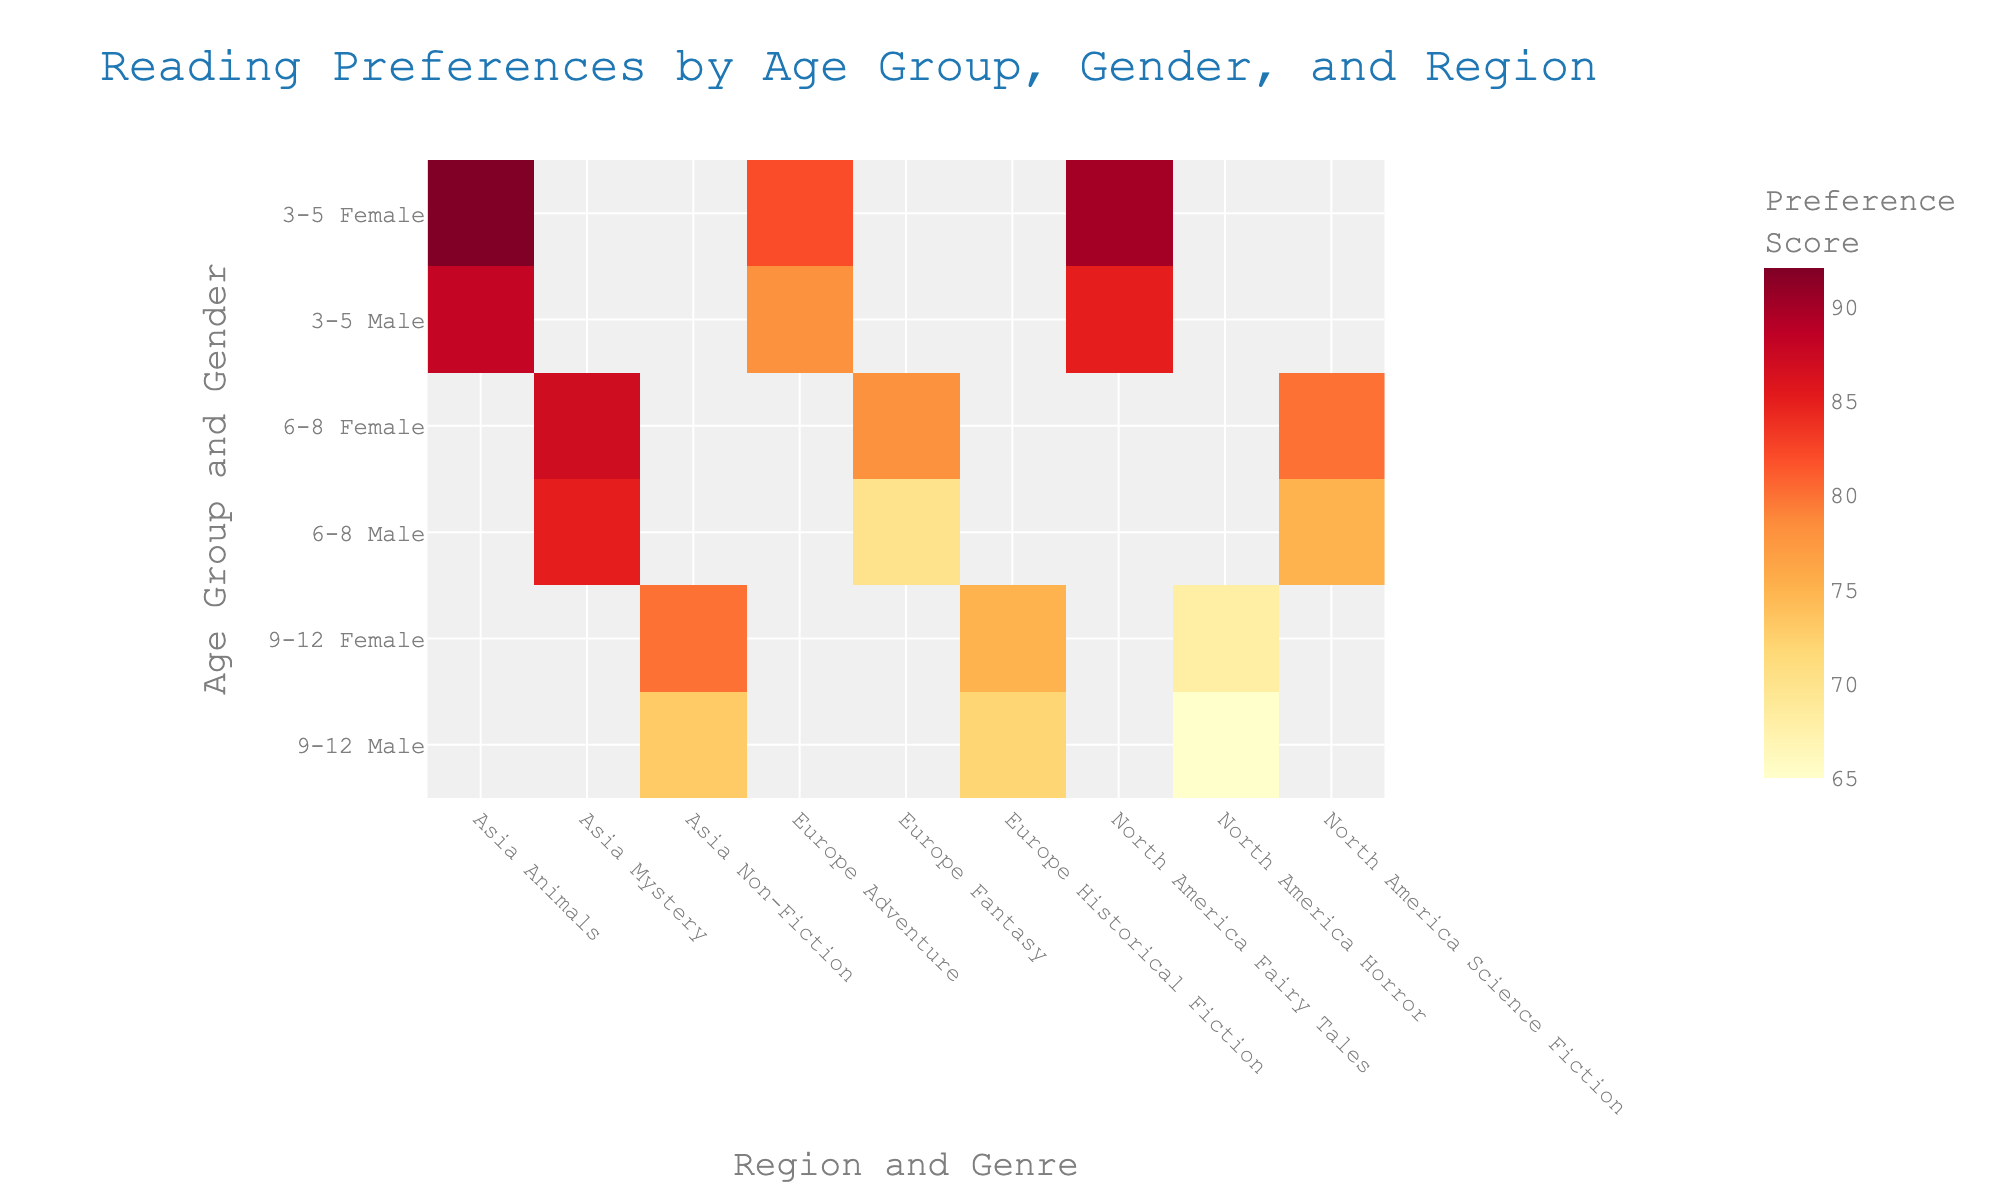what is the title of the heatmap? The title of the heatmap is typically shown at the top of the figure. In this case, the figure is titled "Reading Preferences by Age Group, Gender, and Region."
Answer: Reading Preferences by Age Group, Gender, and Region Which age group and gender in North America has the highest preference score for Science Fiction? Look along the y-axis to find "6-8\nMale" and "6-8\nFemale". Then move horizontally to the column labeled "North America\nScience Fiction". Compare the scores. The female score (80) is higher than the male score (75).
Answer: Female Which genre did 3-5-year-olds in Europe show the most preference for? Look along the y-axis to find "3-5\nMale" and "3-5\nFemale". Then move horizontally within the columns for Europe. Both genders show preference for Adventure, with scores of 78 (males) and 82 (females).
Answer: Adventure Compare the preference scores for 9-12-year-old males in Asia for Non-Fiction with females. Which gender has the higher score and by how much? Find "9-12\nMale" and "9-12\nFemale" in the rows. Find "Asia\nNon-Fiction" in the columns. Males have a score of 73 and females have 80. The difference is 80 - 73 = 7.
Answer: Female, by 7 What is the overall highest preference score observed in the heatmap, and who does it belong to? Scan the entire heatmap for the highest score. The highest score is 92. It belongs to females in the 3-5 age group in Asia for Animals.
Answer: 92, Females 3-5 in Asia for Animals What is the average preference score for Males aged 6-8 across all regions and genres? Find the scores for "6-8\nMale" across all columns. Those scores are 75 (North America), 70 (Europe), 85 (Asia). Calculate the average: (75 + 70 + 85) / 3 = 76.67.
Answer: 76.67 Which region shows the lowest preference score for 9-12-year-old females, and what is that score? Find "9-12\nFemale" across all regions. The scores are 68 (North America), 75 (Europe), and 80 (Asia). The lowest score is 68 in North America for Horror.
Answer: North America, 68 Compare the preference scores for 3-5-year-olds in North America by gender. Which gender scores higher for Fairy Tales, and by how much? Look for "3-5\nMale" and "3-5\nFemale" in the rows, then find the column "North America\nFairy Tales". Males score 85, and females score 90. The difference is 90 - 85 = 5.
Answer: Female, by 5 In Europe, which genre do 6-8-year-old females prefer the most? Find "6-8\nFemale" in the y-axis rows and then look at the columns for Europe. There is only one genre listed, which is Fantasy, with a preference score of 78.
Answer: Fantasy 